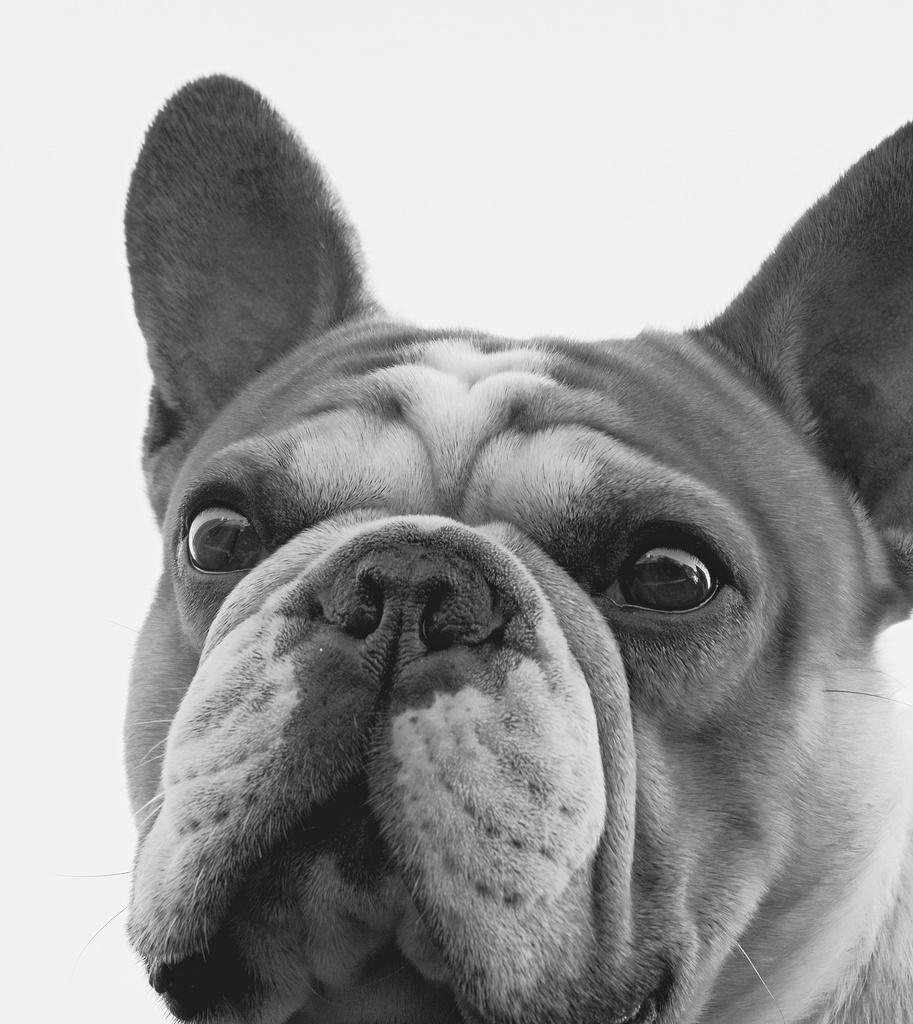What type of picture is in the image? The image contains a black and white picture. What subject is depicted in the picture? The picture is of a dog. What type of note is the dog holding in the image? There is no note present in the image, as it features a black and white picture of a dog. What type of laborer is depicted working in the background of the image? There is no laborer present in the image; it only contains a black and white picture of a dog. 